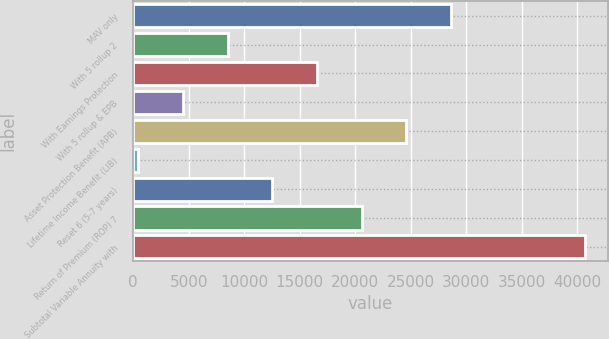<chart> <loc_0><loc_0><loc_500><loc_500><bar_chart><fcel>MAV only<fcel>With 5 rollup 2<fcel>With Earnings Protection<fcel>With 5 rollup & EPB<fcel>Asset Protection Benefit (APB)<fcel>Lifetime Income Benefit (LIB)<fcel>Reset 6 (5-7 years)<fcel>Return of Premium (ROP) 7<fcel>Subtotal Variable Annuity with<nl><fcel>28627.8<fcel>8510.8<fcel>16557.6<fcel>4487.4<fcel>24604.4<fcel>464<fcel>12534.2<fcel>20581<fcel>40698<nl></chart> 